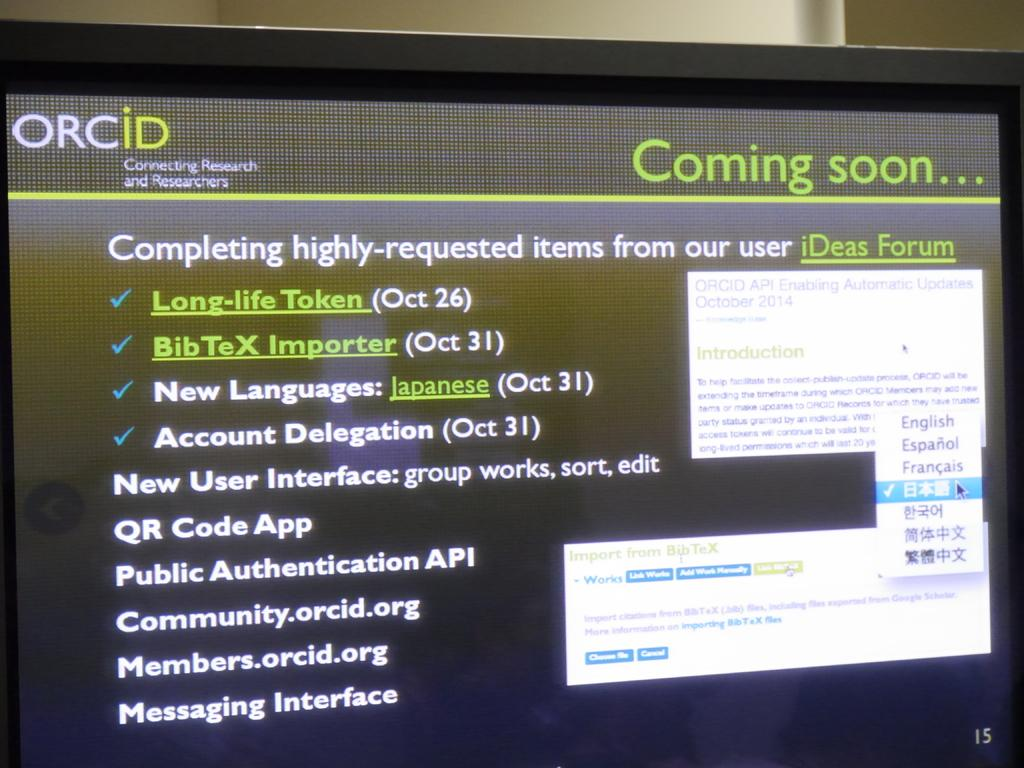<image>
Describe the image concisely. A list of highly requested items are displayed on a computer screen. 